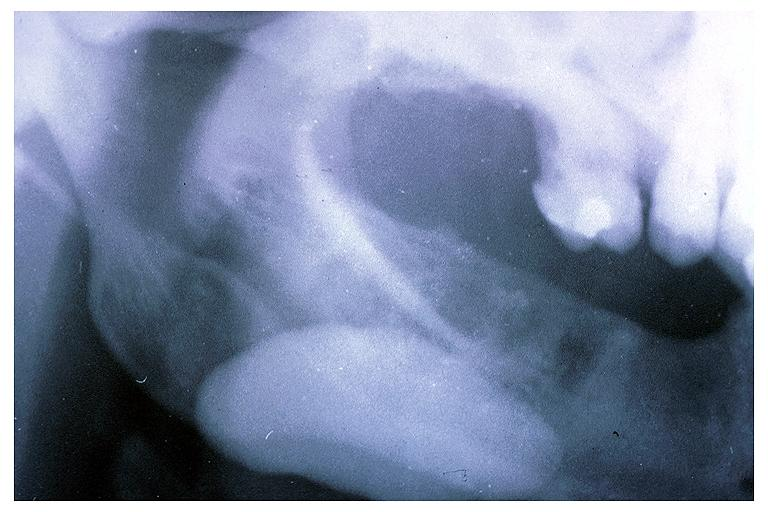does this image show sialolith?
Answer the question using a single word or phrase. Yes 